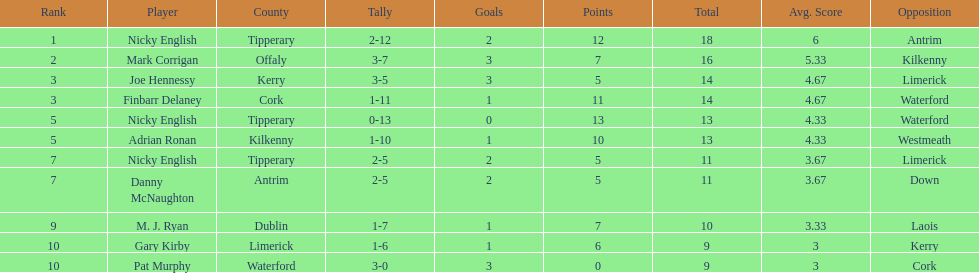How many people are on the list? 9. 